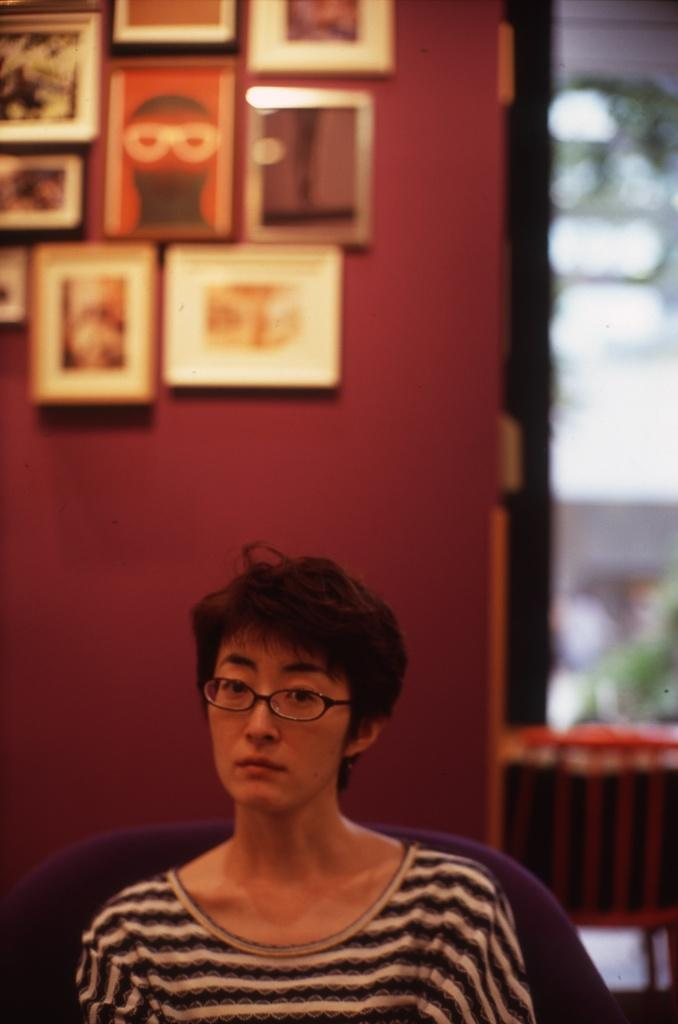What is the person in the image doing? The person is sitting on a chair in the image. What can be seen in the background of the image? There is a wall with photo frames in the background of the image. What grade did the person receive on their latest exam, as shown in the image? There is no information about an exam or a grade in the image. 